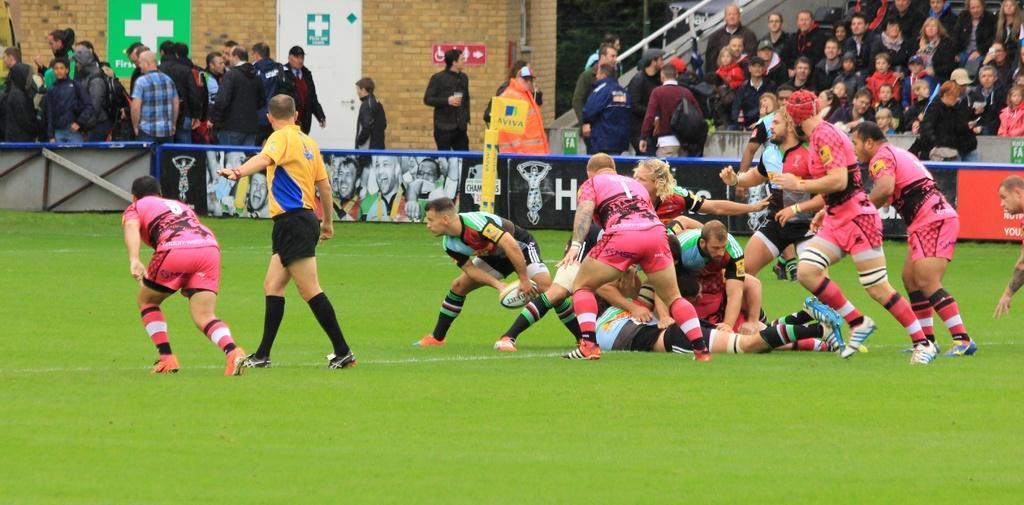In one or two sentences, can you explain what this image depicts? In this image there are few people playing in ground in which one of them holds a ball, there are few people in the stands and few people near the stands, there are posters attached to the wall and banners to the small fences. 